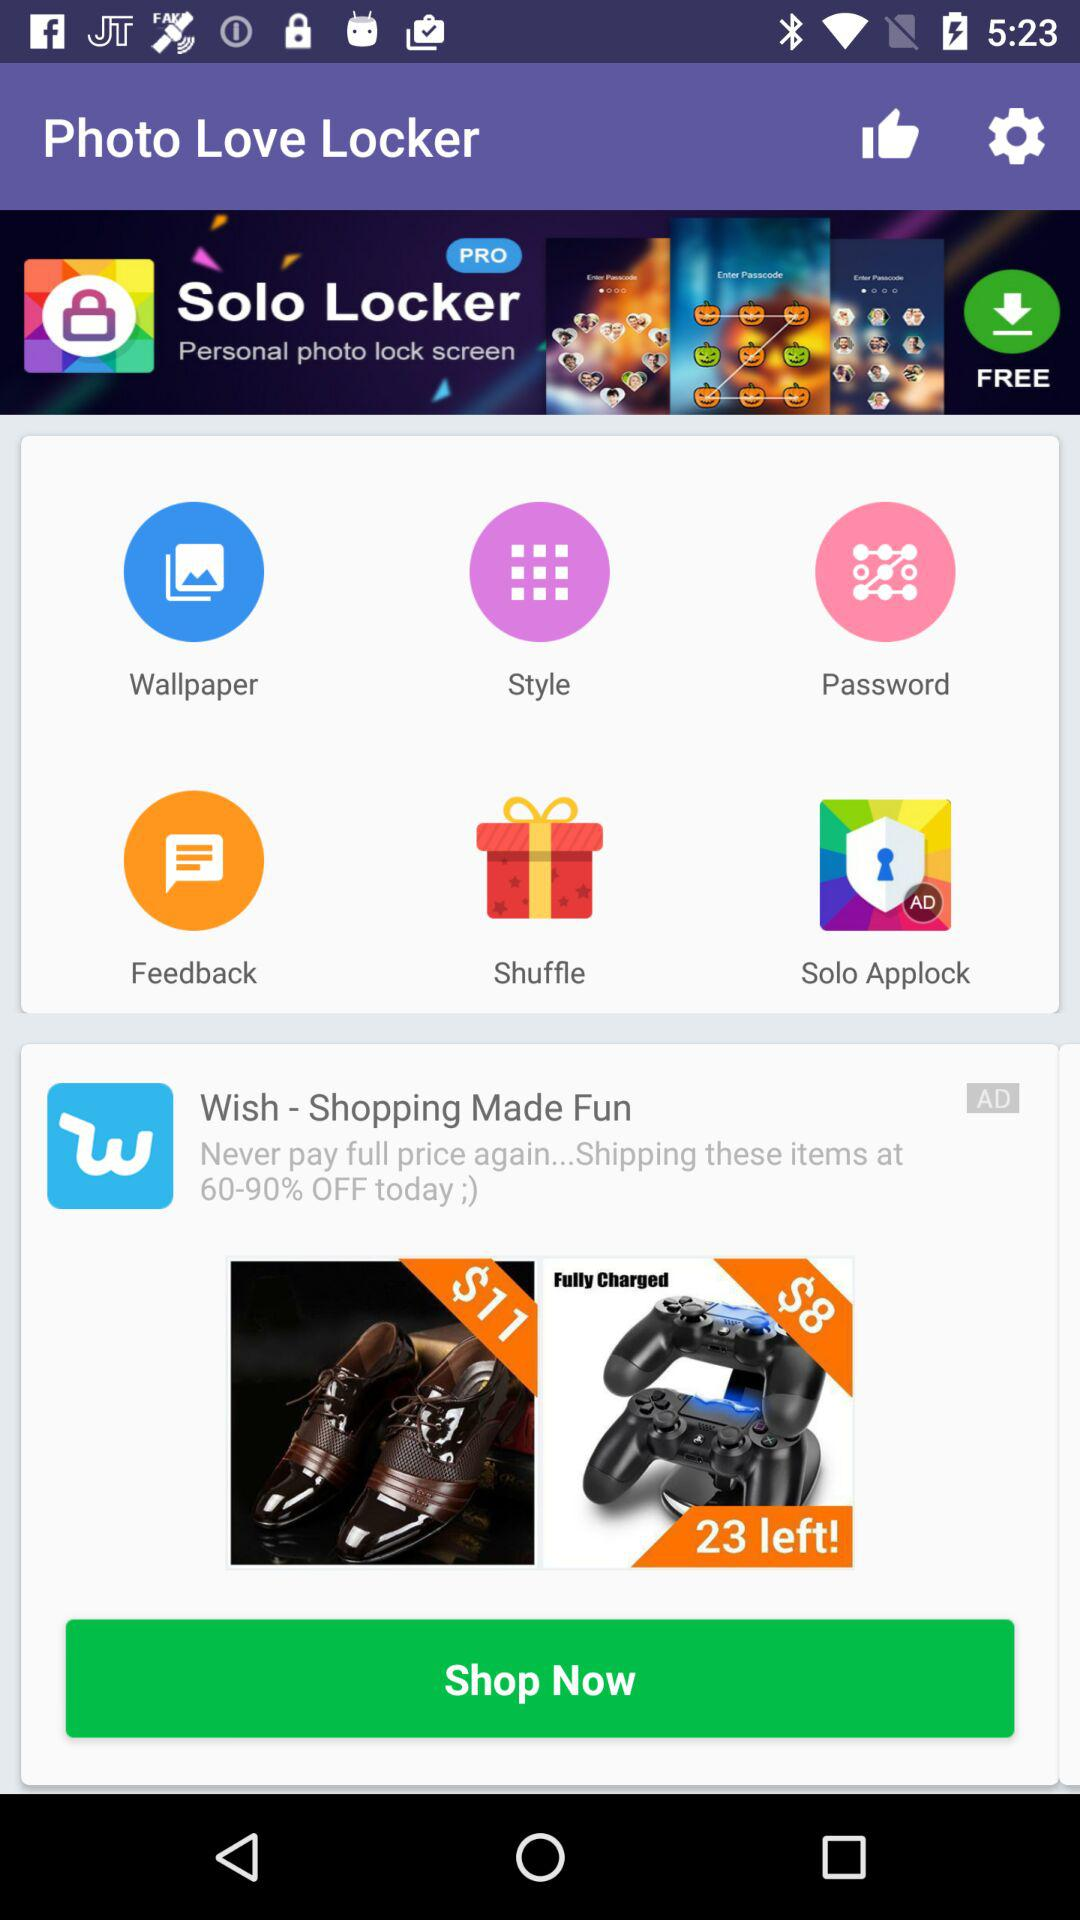What is the name of the application? The names of the applications are "Photo Love Locker" and "Solo Locker". 